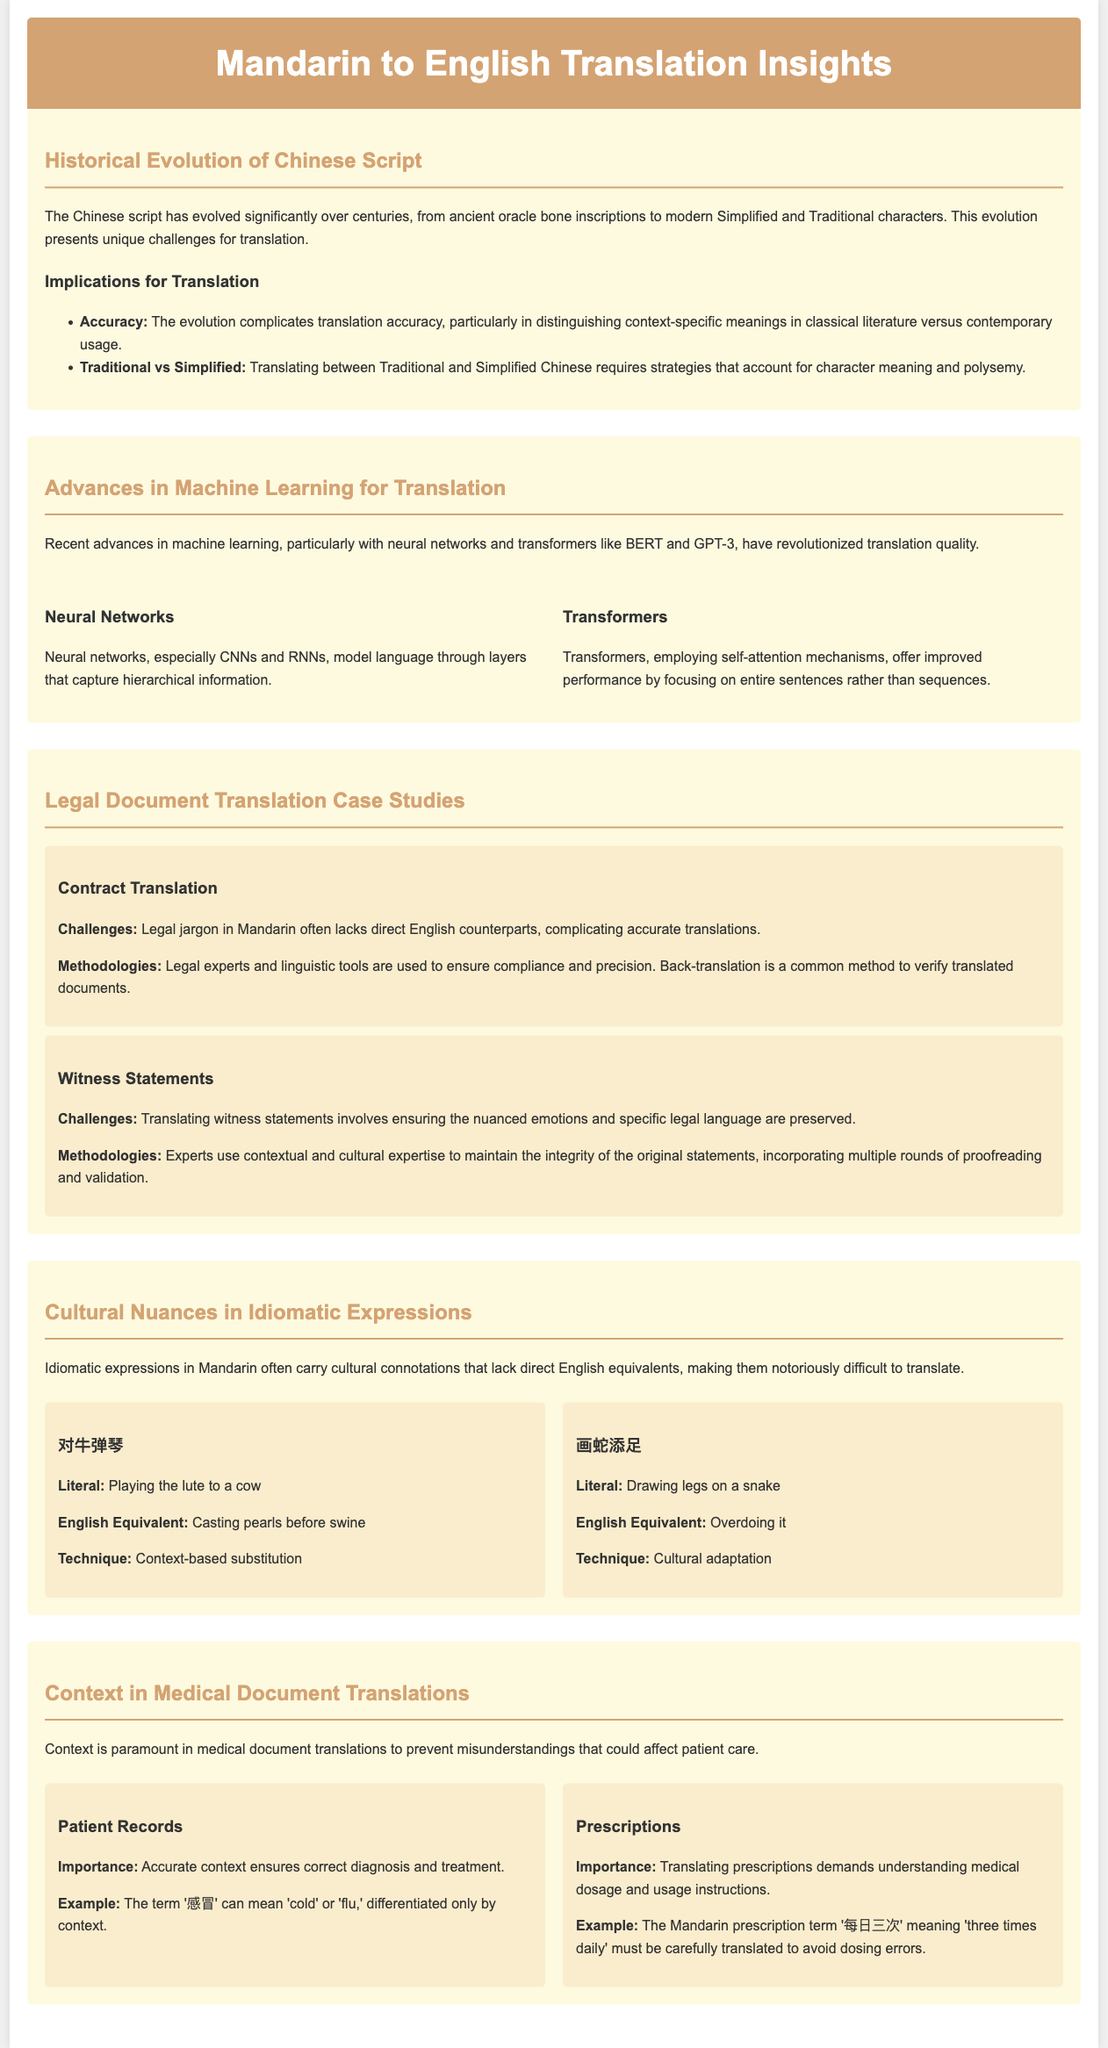What is the title of the document? The title is presented in the header and states the focus of the document.
Answer: Mandarin to English Translation Insights What are the two types of Chinese characters discussed? The document mentions these two types in relation to translation strategies.
Answer: Traditional and Simplified Which machine learning model is mentioned for improving translation accuracy? The document highlights the significance of these advanced models in translation.
Answer: BERT and GPT-3 What idiomatic expression means 'overdoing it'? This specific idiomatic expression illustrates how cultural nuances affect translation.
Answer: 画蛇添足 What is critical in medical document translations to prevent misunderstandings? The document emphasizes this aspect as vital for patient care in translations.
Answer: Context What is a common method used to verify translated legal documents? The document describes this method in relation to ensuring translation compliance.
Answer: Back-translation Which phrase serves as an English equivalent for '对牛弹琴'? The document provides this equivalence to showcase translation techniques for idioms.
Answer: Casting pearls before swine What is the importance of accurate context in patient records? The document explains this in relation to ensuring correct diagnosis and treatment.
Answer: Correct diagnosis and treatment 